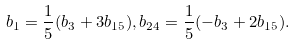Convert formula to latex. <formula><loc_0><loc_0><loc_500><loc_500>b _ { 1 } = \frac { 1 } { 5 } ( b _ { 3 } + 3 b _ { 1 5 } ) , b _ { 2 4 } = \frac { 1 } { 5 } ( - b _ { 3 } + 2 b _ { 1 5 } ) .</formula> 